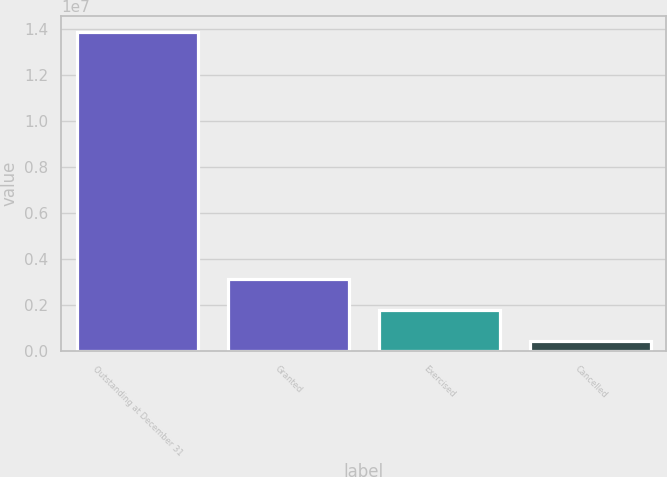<chart> <loc_0><loc_0><loc_500><loc_500><bar_chart><fcel>Outstanding at December 31<fcel>Granted<fcel>Exercised<fcel>Cancelled<nl><fcel>1.38417e+07<fcel>3.12056e+06<fcel>1.78041e+06<fcel>440266<nl></chart> 